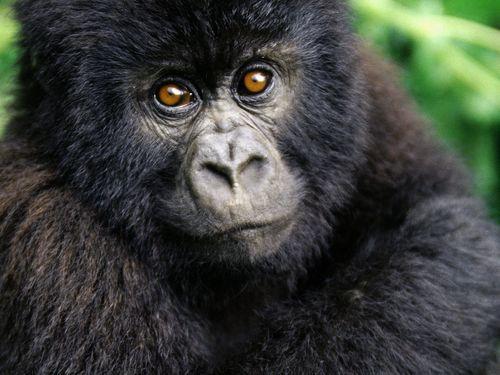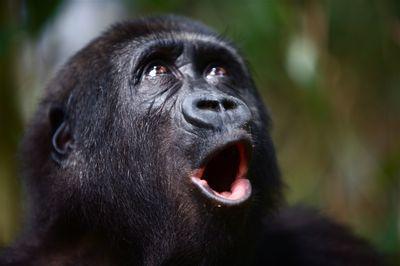The first image is the image on the left, the second image is the image on the right. Considering the images on both sides, is "The gorilla in the right image rests its hand against part of its own body." valid? Answer yes or no. No. 